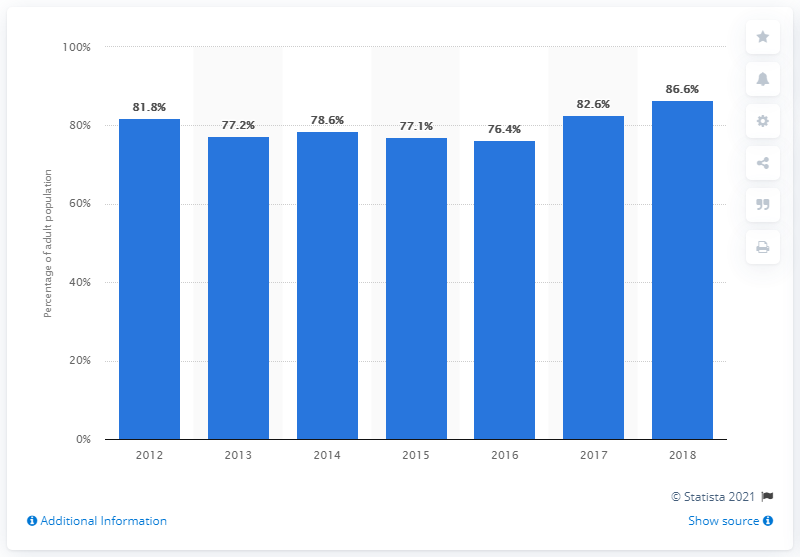Indicate a few pertinent items in this graphic. In 2018, 86.6% of the Malaysian adult population had their credit information covered by a private credit bureau. 